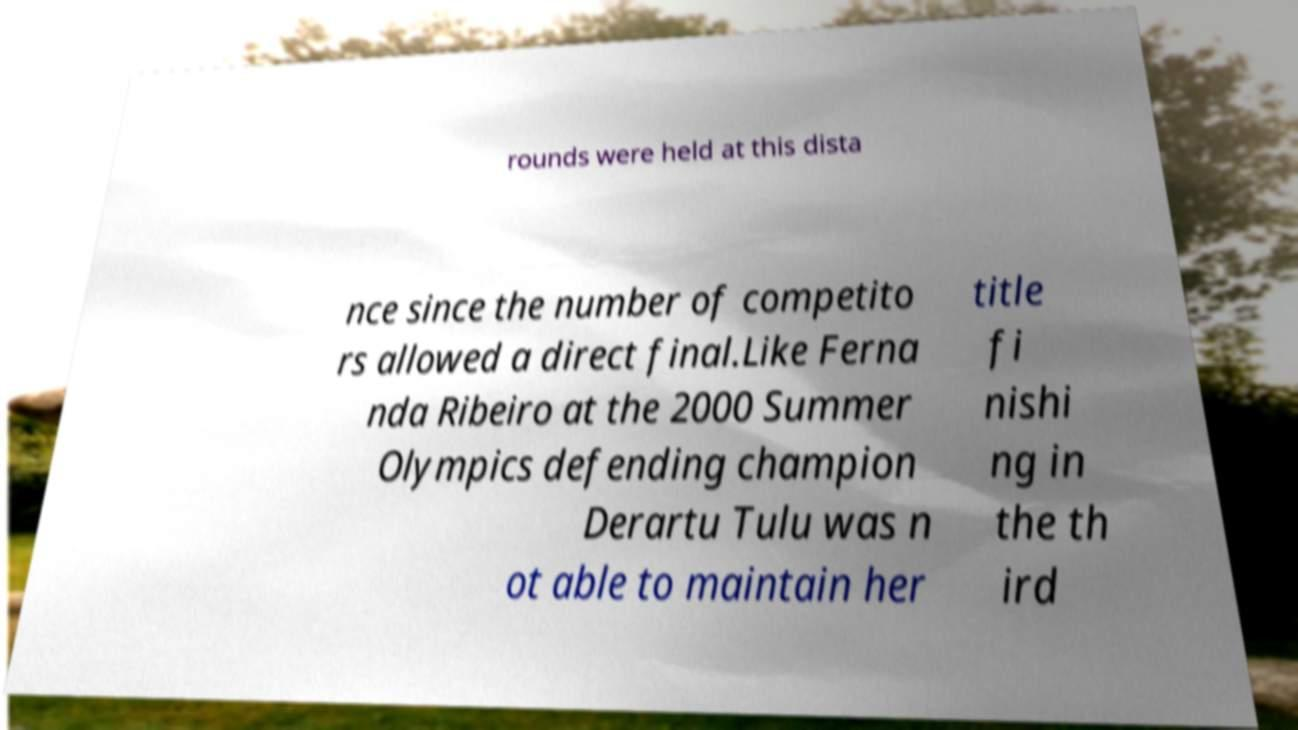Please identify and transcribe the text found in this image. rounds were held at this dista nce since the number of competito rs allowed a direct final.Like Ferna nda Ribeiro at the 2000 Summer Olympics defending champion Derartu Tulu was n ot able to maintain her title fi nishi ng in the th ird 